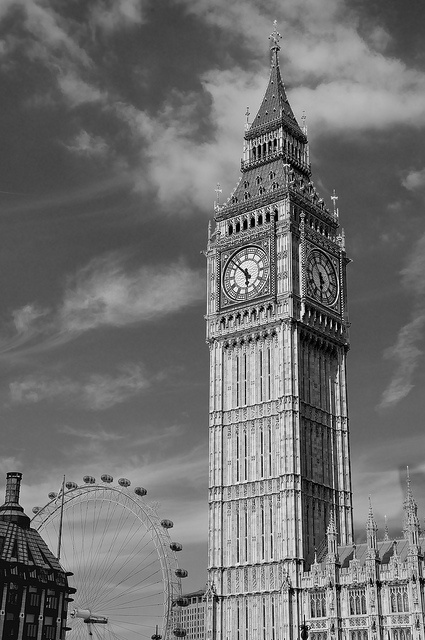Describe the objects in this image and their specific colors. I can see clock in gray, lightgray, darkgray, and black tones and clock in gray, black, and lightgray tones in this image. 